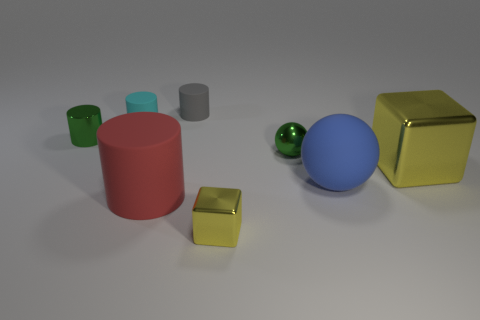Subtract all red cylinders. How many cylinders are left? 3 Subtract all green cylinders. How many cylinders are left? 3 Add 1 small cyan cylinders. How many objects exist? 9 Subtract 1 cylinders. How many cylinders are left? 3 Subtract all brown cylinders. Subtract all green cubes. How many cylinders are left? 4 Subtract all cubes. How many objects are left? 6 Add 2 blue rubber objects. How many blue rubber objects are left? 3 Add 7 brown matte spheres. How many brown matte spheres exist? 7 Subtract 1 blue balls. How many objects are left? 7 Subtract all large red matte cylinders. Subtract all tiny green objects. How many objects are left? 5 